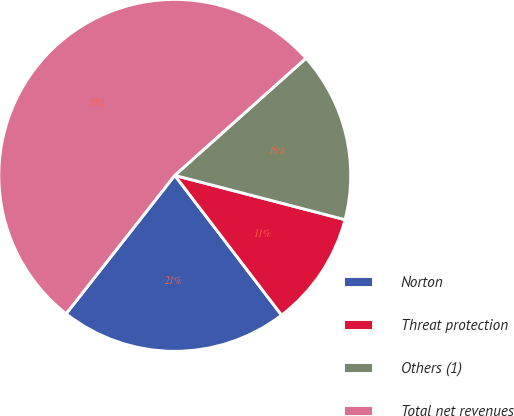Convert chart. <chart><loc_0><loc_0><loc_500><loc_500><pie_chart><fcel>Norton<fcel>Threat protection<fcel>Others (1)<fcel>Total net revenues<nl><fcel>20.98%<fcel>10.56%<fcel>15.65%<fcel>52.81%<nl></chart> 